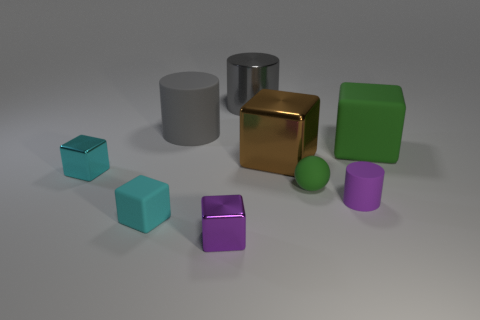There is a cube that is the same color as the small cylinder; what material is it? The cube sharing the same color as the small cylinder appears to exhibit a metallic sheen, suggesting it too is metal, possibly with a brushed finish to give it a subtle luster and texture. 